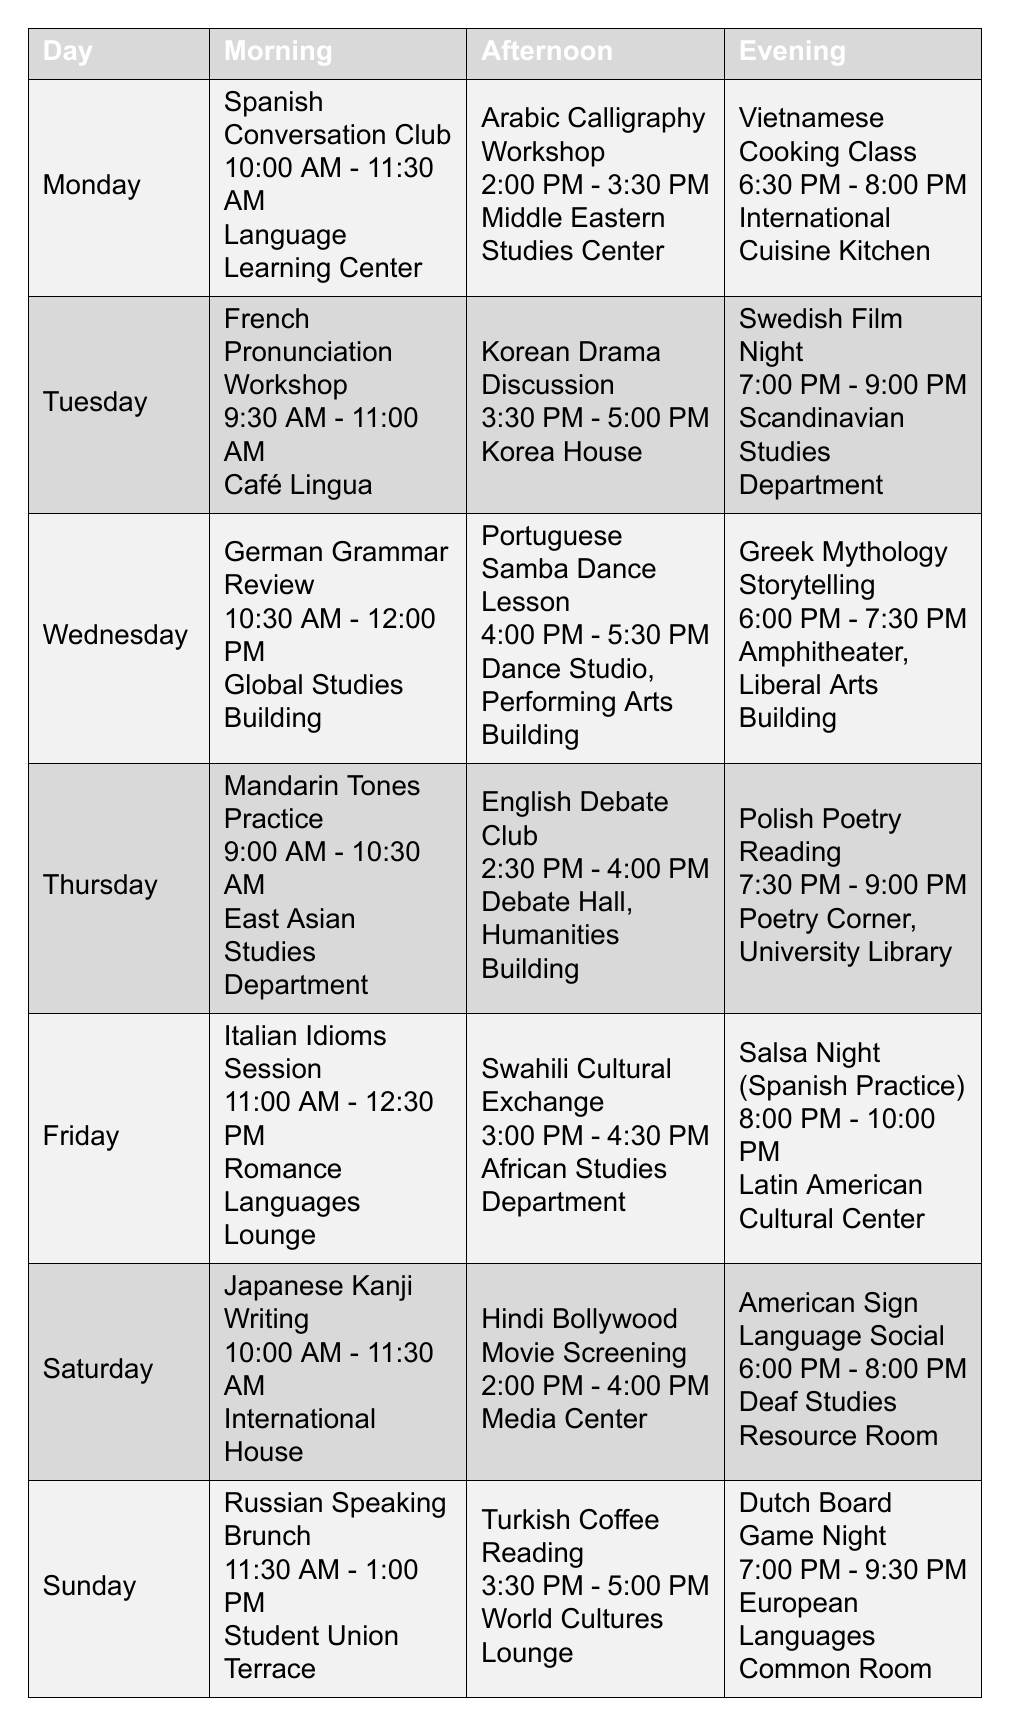What language is practiced in the Monday morning activity? The table indicates that the Monday morning activity is the "Spanish Conversation Club."
Answer: Spanish What time does the Wednesday afternoon activity start? According to the table, the Wednesday afternoon activity, "Portuguese Samba Dance Lesson," starts at 4:00 PM.
Answer: 4:00 PM Which location hosts the Tuesday evening activity? The Tuesday evening activity is the "Swedish Film Night," which is held at the Scandinavian Studies Department.
Answer: Scandinavian Studies Department Is there a cooking class offered during the week? Yes, there is a "Vietnamese Cooking Class" on Monday evening.
Answer: Yes On which day can you attend a cultural exchange activity? The table shows that there are two cultural exchange activities: "Swahili Cultural Exchange" on Friday and "Turkish Coffee Reading" on Sunday.
Answer: Friday and Sunday What activity ends the latest on Saturday? The "American Sign Language Social" ends at 8:00 PM on Saturday.
Answer: American Sign Language Social Which day has the earliest morning activity? The earliest morning activity is the "Mandarin Tones Practice" on Thursday starting at 9:00 AM.
Answer: Thursday Which language activities are scheduled in the afternoon on Friday? The afternoon activity on Friday is "Swahili Cultural Exchange" from 3:00 PM to 4:30 PM.
Answer: Swahili Cultural Exchange How many evening activities are focused on language practice? There are three evening activities focused on language practice: "Salsa Night (Spanish Practice)" on Friday, "Vietnamese Cooking Class" on Monday, and "Polish Poetry Reading" on Thursday.
Answer: Three Which morning activity takes place in the Global Studies Building? The morning activity held in the Global Studies Building is the "German Grammar Review" on Wednesday.
Answer: German Grammar Review What are the locations for all of the weekend activities? On Saturday, the activities are at "International House," "Media Center," and "Deaf Studies Resource Room"; on Sunday, the locations are "Student Union Terrace," "World Cultures Lounge," and "European Languages Common Room."
Answer: Various locations including Student Union Terrace and Media Center What is the difference in start times between the Monday and Thursday morning activities? The Monday morning activity starts at 10:00 AM, while the Thursday activity starts at 9:00 AM. The difference is 1 hour.
Answer: 1 hour Which day has both an Arabic and a Korean activity? Monday features an Arabic activity in the afternoon, while Tuesday has a Korean activity. Thus, no single day features both.
Answer: No day 